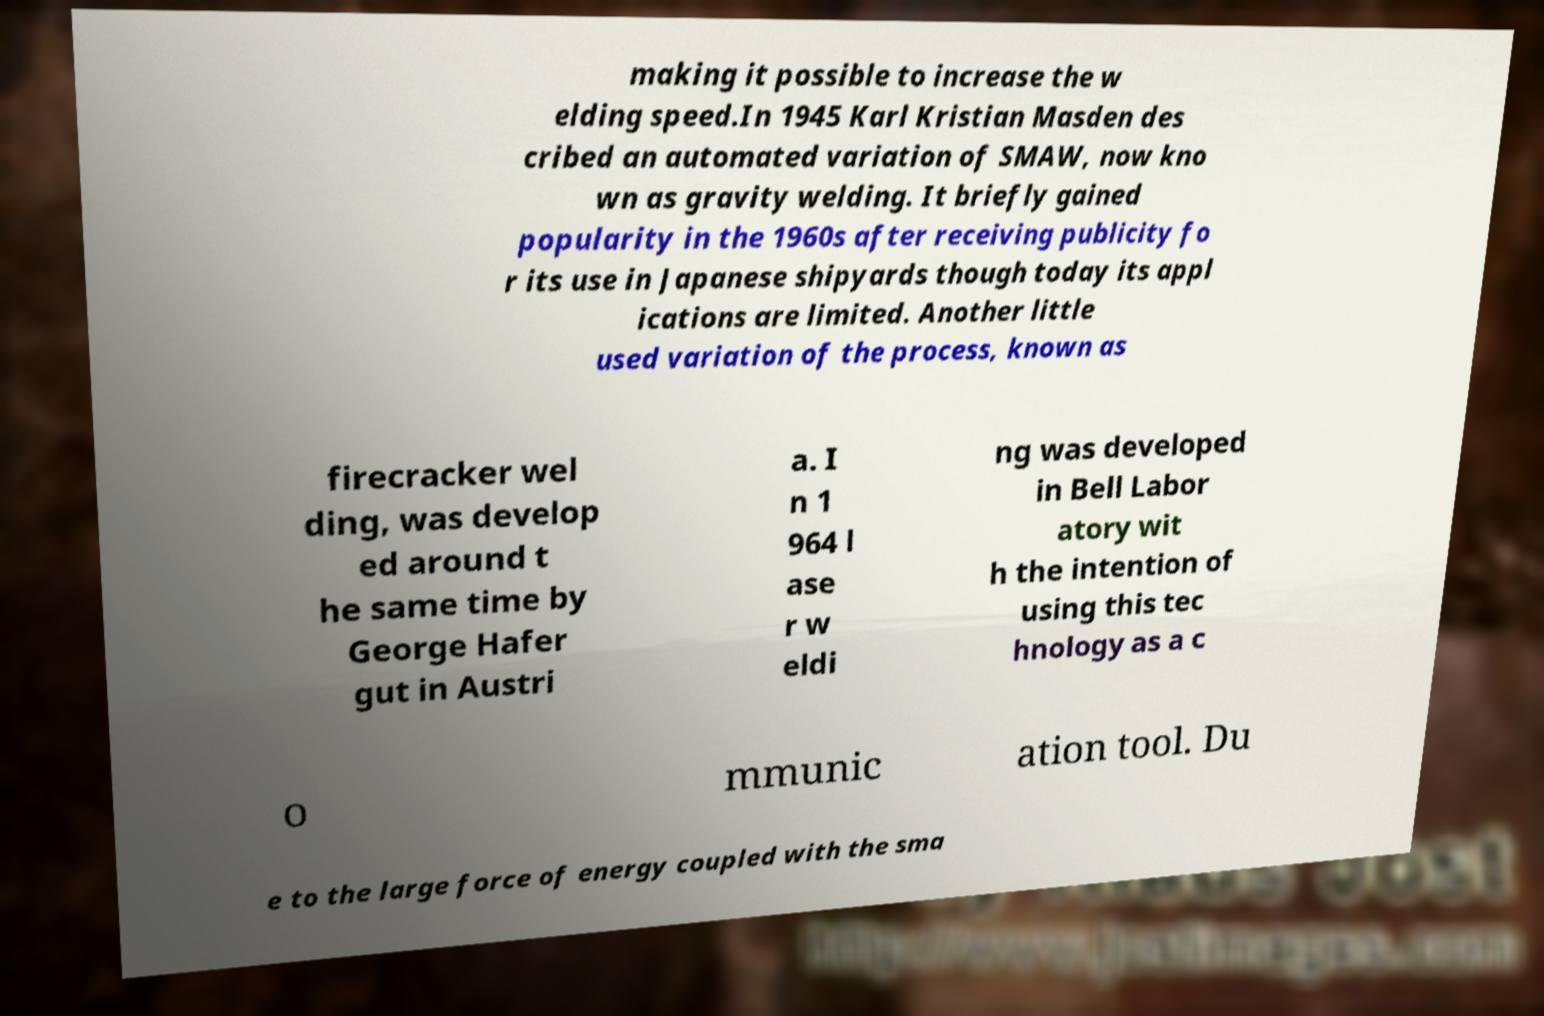Can you accurately transcribe the text from the provided image for me? making it possible to increase the w elding speed.In 1945 Karl Kristian Masden des cribed an automated variation of SMAW, now kno wn as gravity welding. It briefly gained popularity in the 1960s after receiving publicity fo r its use in Japanese shipyards though today its appl ications are limited. Another little used variation of the process, known as firecracker wel ding, was develop ed around t he same time by George Hafer gut in Austri a. I n 1 964 l ase r w eldi ng was developed in Bell Labor atory wit h the intention of using this tec hnology as a c o mmunic ation tool. Du e to the large force of energy coupled with the sma 